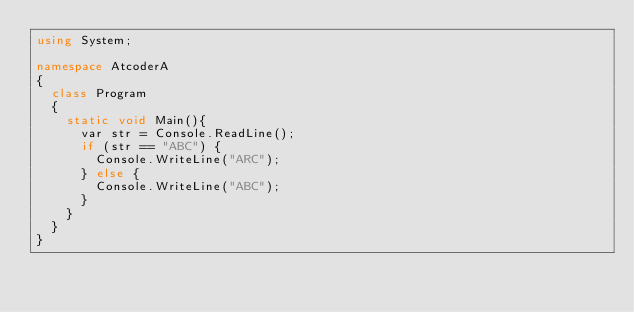Convert code to text. <code><loc_0><loc_0><loc_500><loc_500><_C#_>using System;

namespace AtcoderA
{
  class Program
  {
    static void Main(){
      var str = Console.ReadLine();
      if (str == "ABC") {
        Console.WriteLine("ARC");
      } else {
        Console.WriteLine("ABC");
      }
    }
  }
}
</code> 